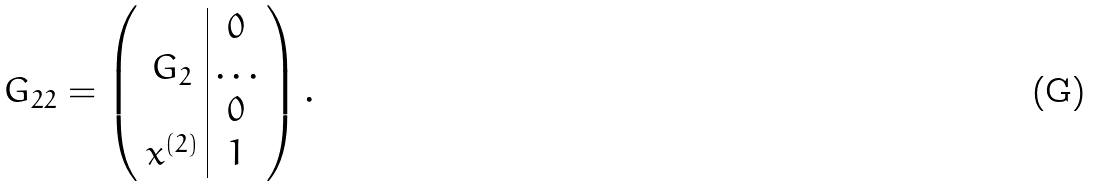<formula> <loc_0><loc_0><loc_500><loc_500>G _ { 2 2 } = \left ( \begin{array} { c | c } & 0 \\ G _ { 2 } & \dots \\ & 0 \\ x ^ { ( 2 ) } & 1 \end{array} \right ) .</formula> 